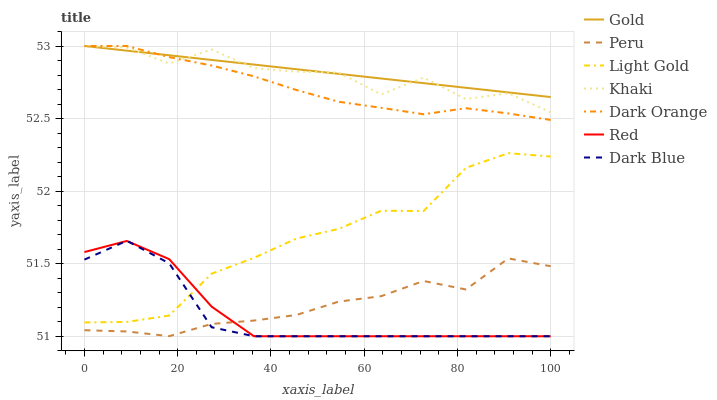Does Khaki have the minimum area under the curve?
Answer yes or no. No. Does Khaki have the maximum area under the curve?
Answer yes or no. No. Is Khaki the smoothest?
Answer yes or no. No. Is Gold the roughest?
Answer yes or no. No. Does Khaki have the lowest value?
Answer yes or no. No. Does Dark Blue have the highest value?
Answer yes or no. No. Is Red less than Dark Orange?
Answer yes or no. Yes. Is Gold greater than Dark Blue?
Answer yes or no. Yes. Does Red intersect Dark Orange?
Answer yes or no. No. 